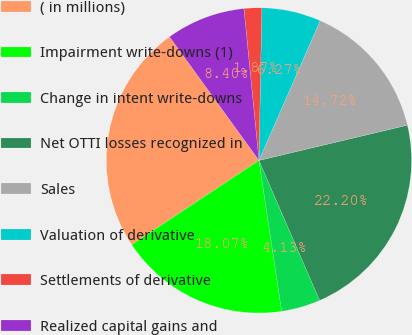<chart> <loc_0><loc_0><loc_500><loc_500><pie_chart><fcel>( in millions)<fcel>Impairment write-downs (1)<fcel>Change in intent write-downs<fcel>Net OTTI losses recognized in<fcel>Sales<fcel>Valuation of derivative<fcel>Settlements of derivative<fcel>Realized capital gains and<nl><fcel>24.34%<fcel>18.07%<fcel>4.13%<fcel>22.2%<fcel>14.72%<fcel>6.27%<fcel>1.87%<fcel>8.4%<nl></chart> 